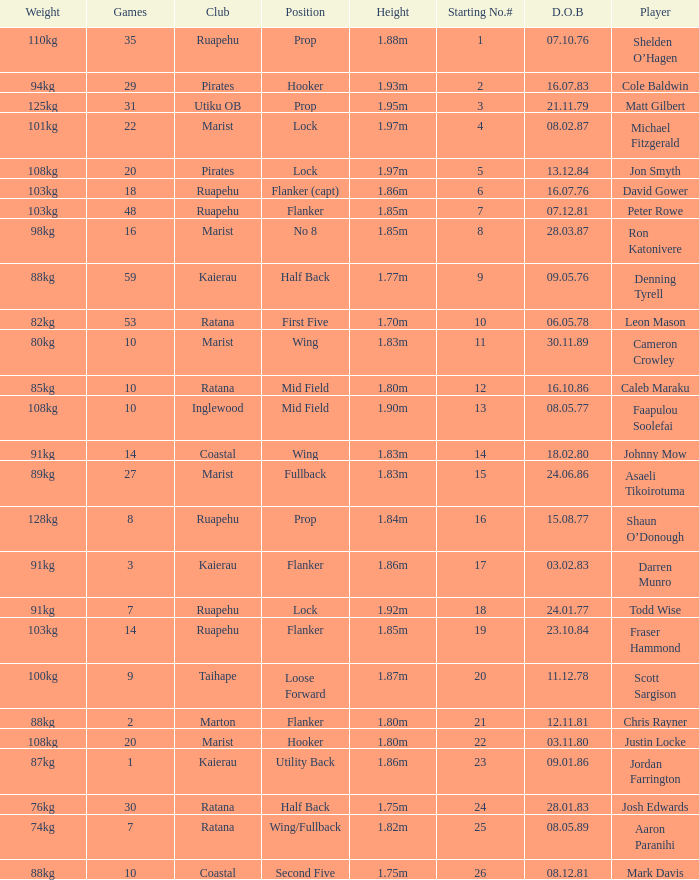Which player weighs 76kg? Josh Edwards. 